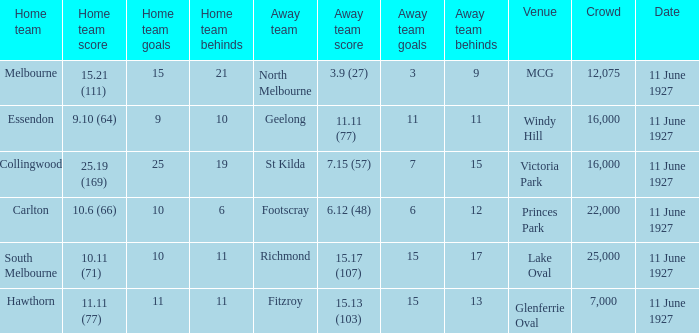How many people were present in a total of every crowd at the MCG venue? 12075.0. 